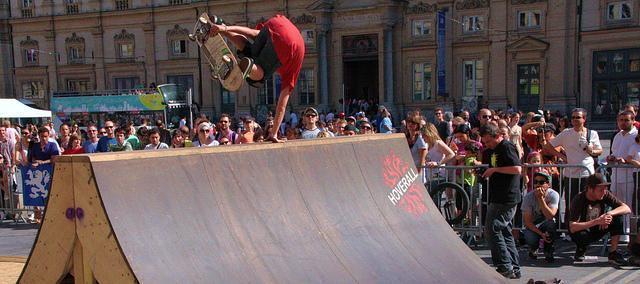How many people are in the picture?
Give a very brief answer. 3. 